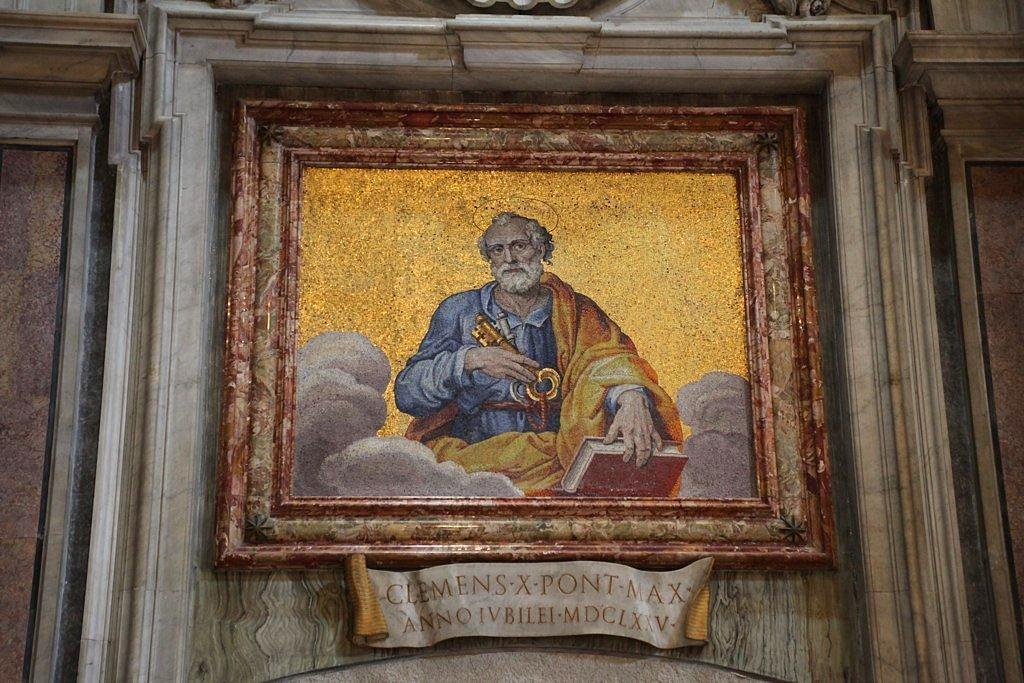Provide a one-sentence caption for the provided image. An old picture in a frame which reads Clemens Xpont Max. 